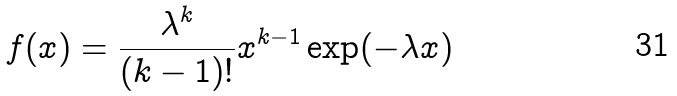<formula> <loc_0><loc_0><loc_500><loc_500>f ( x ) = { \frac { \lambda ^ { k } } { ( k - 1 ) ! } } x ^ { k - 1 } \exp ( - \lambda x )</formula> 